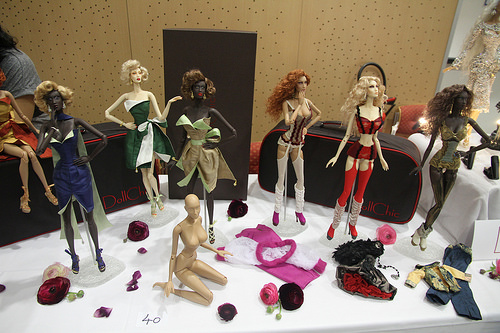<image>
Is the doll behind the clothing? Yes. From this viewpoint, the doll is positioned behind the clothing, with the clothing partially or fully occluding the doll. Is there a barbie on the flower? No. The barbie is not positioned on the flower. They may be near each other, but the barbie is not supported by or resting on top of the flower. 